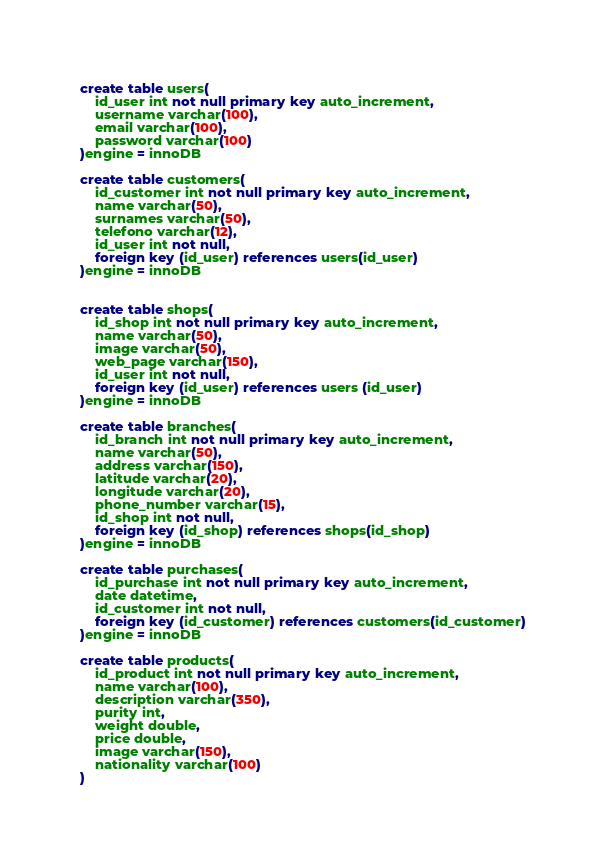<code> <loc_0><loc_0><loc_500><loc_500><_SQL_>create table users(
	id_user int not null primary key auto_increment,
	username varchar(100),
	email varchar(100),
	password varchar(100)
)engine = innoDB

create table customers(
	id_customer int not null primary key auto_increment,
	name varchar(50),
	surnames varchar(50),
	telefono varchar(12),
	id_user int not null,
	foreign key (id_user) references users(id_user)
)engine = innoDB


create table shops(
	id_shop int not null primary key auto_increment,
	name varchar(50),
	image varchar(50),
	web_page varchar(150),
	id_user int not null,
	foreign key (id_user) references users (id_user)
)engine = innoDB

create table branches(
	id_branch int not null primary key auto_increment,
	name varchar(50),
	address varchar(150),
	latitude varchar(20),
	longitude varchar(20),
	phone_number varchar(15),
	id_shop int not null,
	foreign key (id_shop) references shops(id_shop)
)engine = innoDB

create table purchases(
	id_purchase int not null primary key auto_increment,
	date datetime,
	id_customer int not null,
	foreign key (id_customer) references customers(id_customer)
)engine = innoDB

create table products(
	id_product int not null primary key auto_increment,
	name varchar(100),
	description varchar(350),
	purity int,
	weight double,
	price double,
	image varchar(150),
	nationality varchar(100)
)
</code> 